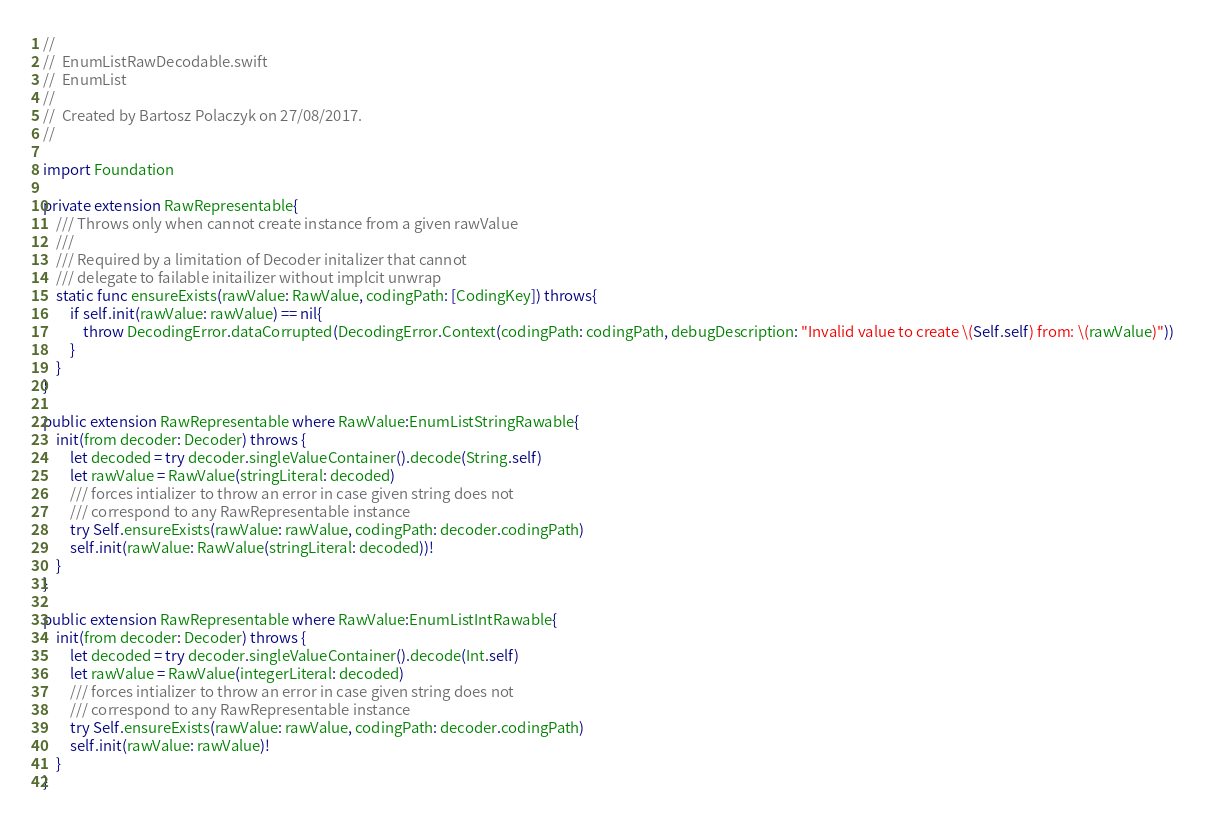Convert code to text. <code><loc_0><loc_0><loc_500><loc_500><_Swift_>//
//  EnumListRawDecodable.swift
//  EnumList
//
//  Created by Bartosz Polaczyk on 27/08/2017.
//

import Foundation

private extension RawRepresentable{
    /// Throws only when cannot create instance from a given rawValue
    ///
    /// Required by a limitation of Decoder initalizer that cannot
    /// delegate to failable initailizer without implcit unwrap
    static func ensureExists(rawValue: RawValue, codingPath: [CodingKey]) throws{
        if self.init(rawValue: rawValue) == nil{
            throw DecodingError.dataCorrupted(DecodingError.Context(codingPath: codingPath, debugDescription: "Invalid value to create \(Self.self) from: \(rawValue)"))
        }
    }
}

public extension RawRepresentable where RawValue:EnumListStringRawable{
    init(from decoder: Decoder) throws {
        let decoded = try decoder.singleValueContainer().decode(String.self)
        let rawValue = RawValue(stringLiteral: decoded)
        /// forces intializer to throw an error in case given string does not
        /// correspond to any RawRepresentable instance
        try Self.ensureExists(rawValue: rawValue, codingPath: decoder.codingPath)
        self.init(rawValue: RawValue(stringLiteral: decoded))!
    }
}

public extension RawRepresentable where RawValue:EnumListIntRawable{
    init(from decoder: Decoder) throws {
        let decoded = try decoder.singleValueContainer().decode(Int.self)
        let rawValue = RawValue(integerLiteral: decoded)
        /// forces intializer to throw an error in case given string does not
        /// correspond to any RawRepresentable instance
        try Self.ensureExists(rawValue: rawValue, codingPath: decoder.codingPath)
        self.init(rawValue: rawValue)!
    }
}
</code> 